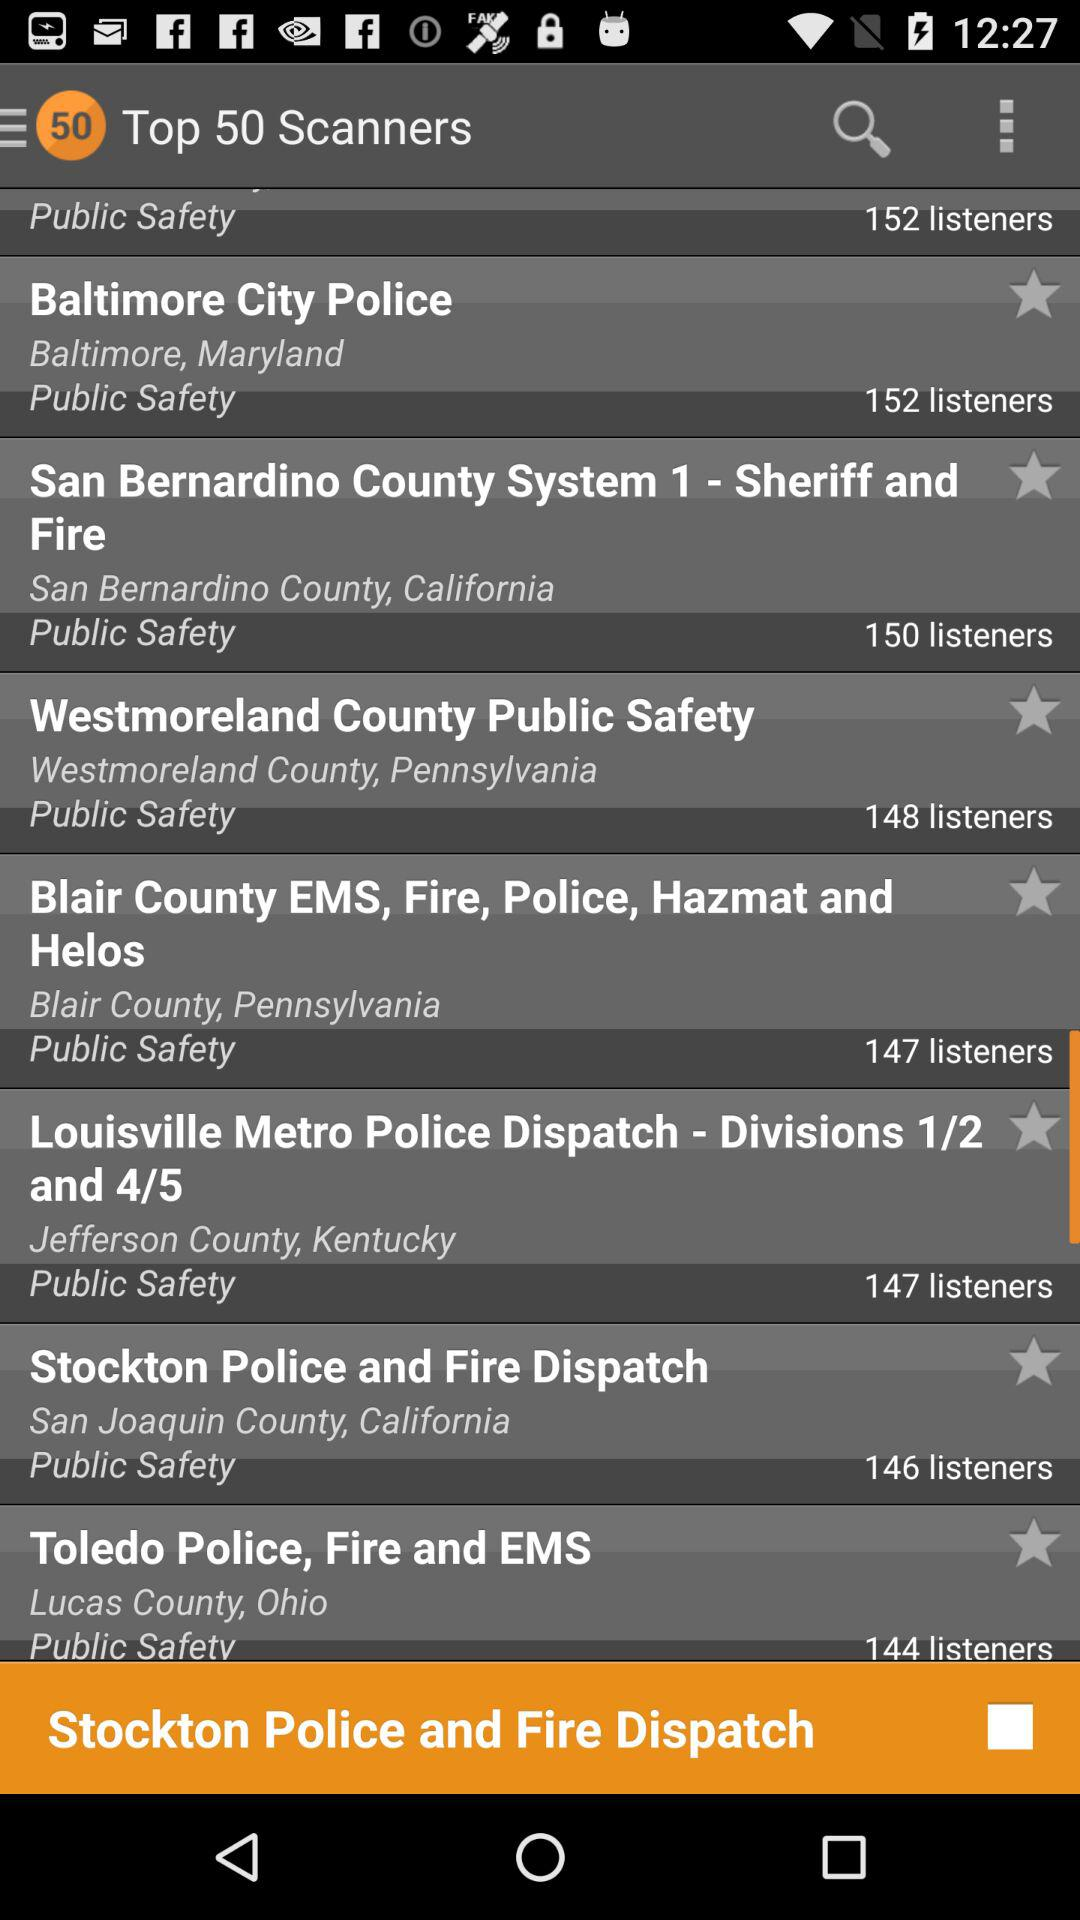What is the total count of the scans? The total count is 50. 